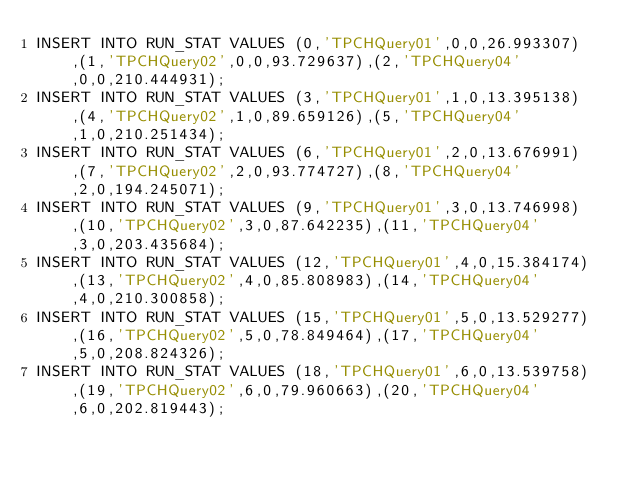Convert code to text. <code><loc_0><loc_0><loc_500><loc_500><_SQL_>INSERT INTO RUN_STAT VALUES (0,'TPCHQuery01',0,0,26.993307),(1,'TPCHQuery02',0,0,93.729637),(2,'TPCHQuery04',0,0,210.444931);
INSERT INTO RUN_STAT VALUES (3,'TPCHQuery01',1,0,13.395138),(4,'TPCHQuery02',1,0,89.659126),(5,'TPCHQuery04',1,0,210.251434);
INSERT INTO RUN_STAT VALUES (6,'TPCHQuery01',2,0,13.676991),(7,'TPCHQuery02',2,0,93.774727),(8,'TPCHQuery04',2,0,194.245071);
INSERT INTO RUN_STAT VALUES (9,'TPCHQuery01',3,0,13.746998),(10,'TPCHQuery02',3,0,87.642235),(11,'TPCHQuery04',3,0,203.435684);
INSERT INTO RUN_STAT VALUES (12,'TPCHQuery01',4,0,15.384174),(13,'TPCHQuery02',4,0,85.808983),(14,'TPCHQuery04',4,0,210.300858);
INSERT INTO RUN_STAT VALUES (15,'TPCHQuery01',5,0,13.529277),(16,'TPCHQuery02',5,0,78.849464),(17,'TPCHQuery04',5,0,208.824326);
INSERT INTO RUN_STAT VALUES (18,'TPCHQuery01',6,0,13.539758),(19,'TPCHQuery02',6,0,79.960663),(20,'TPCHQuery04',6,0,202.819443);</code> 